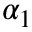Convert formula to latex. <formula><loc_0><loc_0><loc_500><loc_500>\alpha _ { 1 }</formula> 